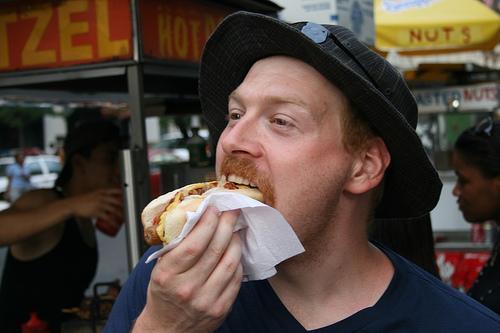How many people are in this photo?
Give a very brief answer. 1. 